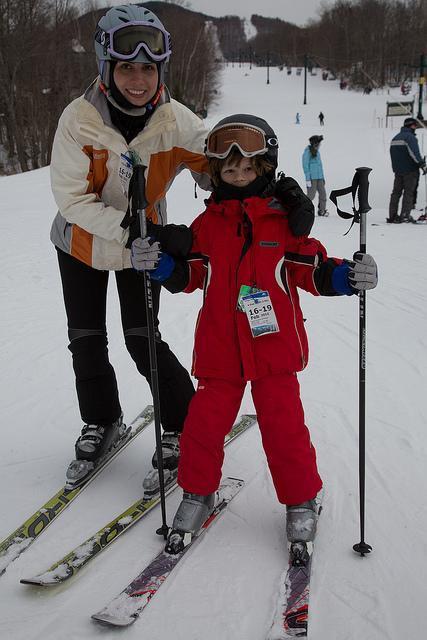How many ski are there?
Give a very brief answer. 2. How many people can be seen?
Give a very brief answer. 3. 